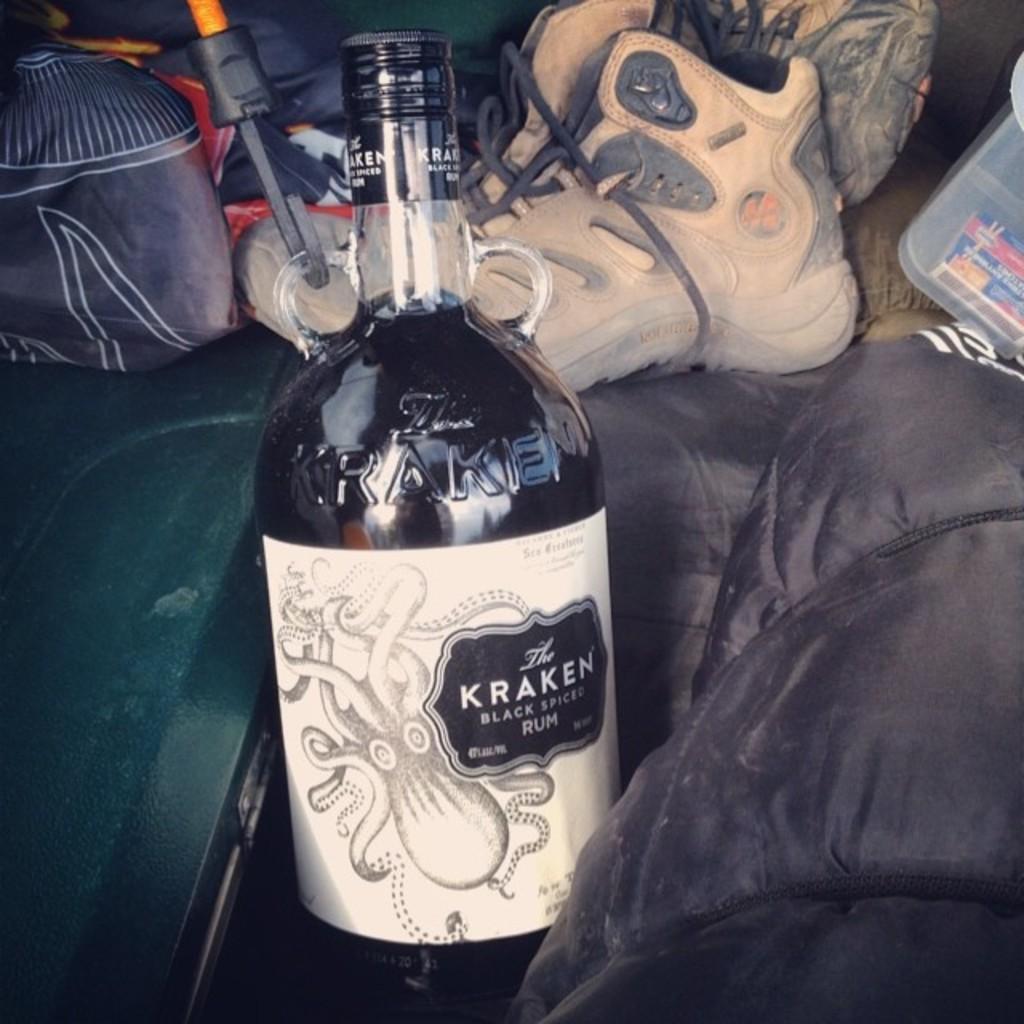Describe this image in one or two sentences. This is a glass bottle with alcohol in it. This bottle is sealed with black cap and label is attached to the bottle. This is the shoe. This looks like a cloth and some objects placed behind the bottle. 